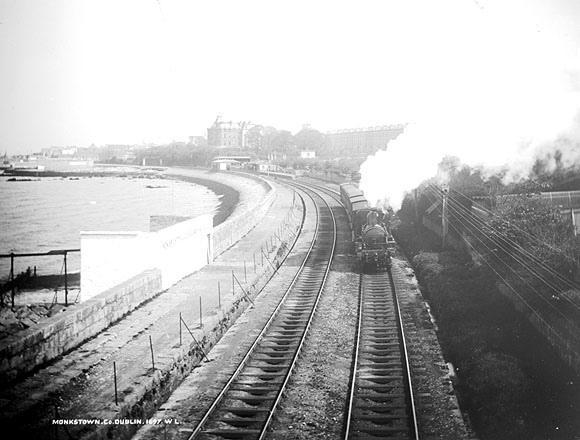How many train tracks are there?
Give a very brief answer. 2. 